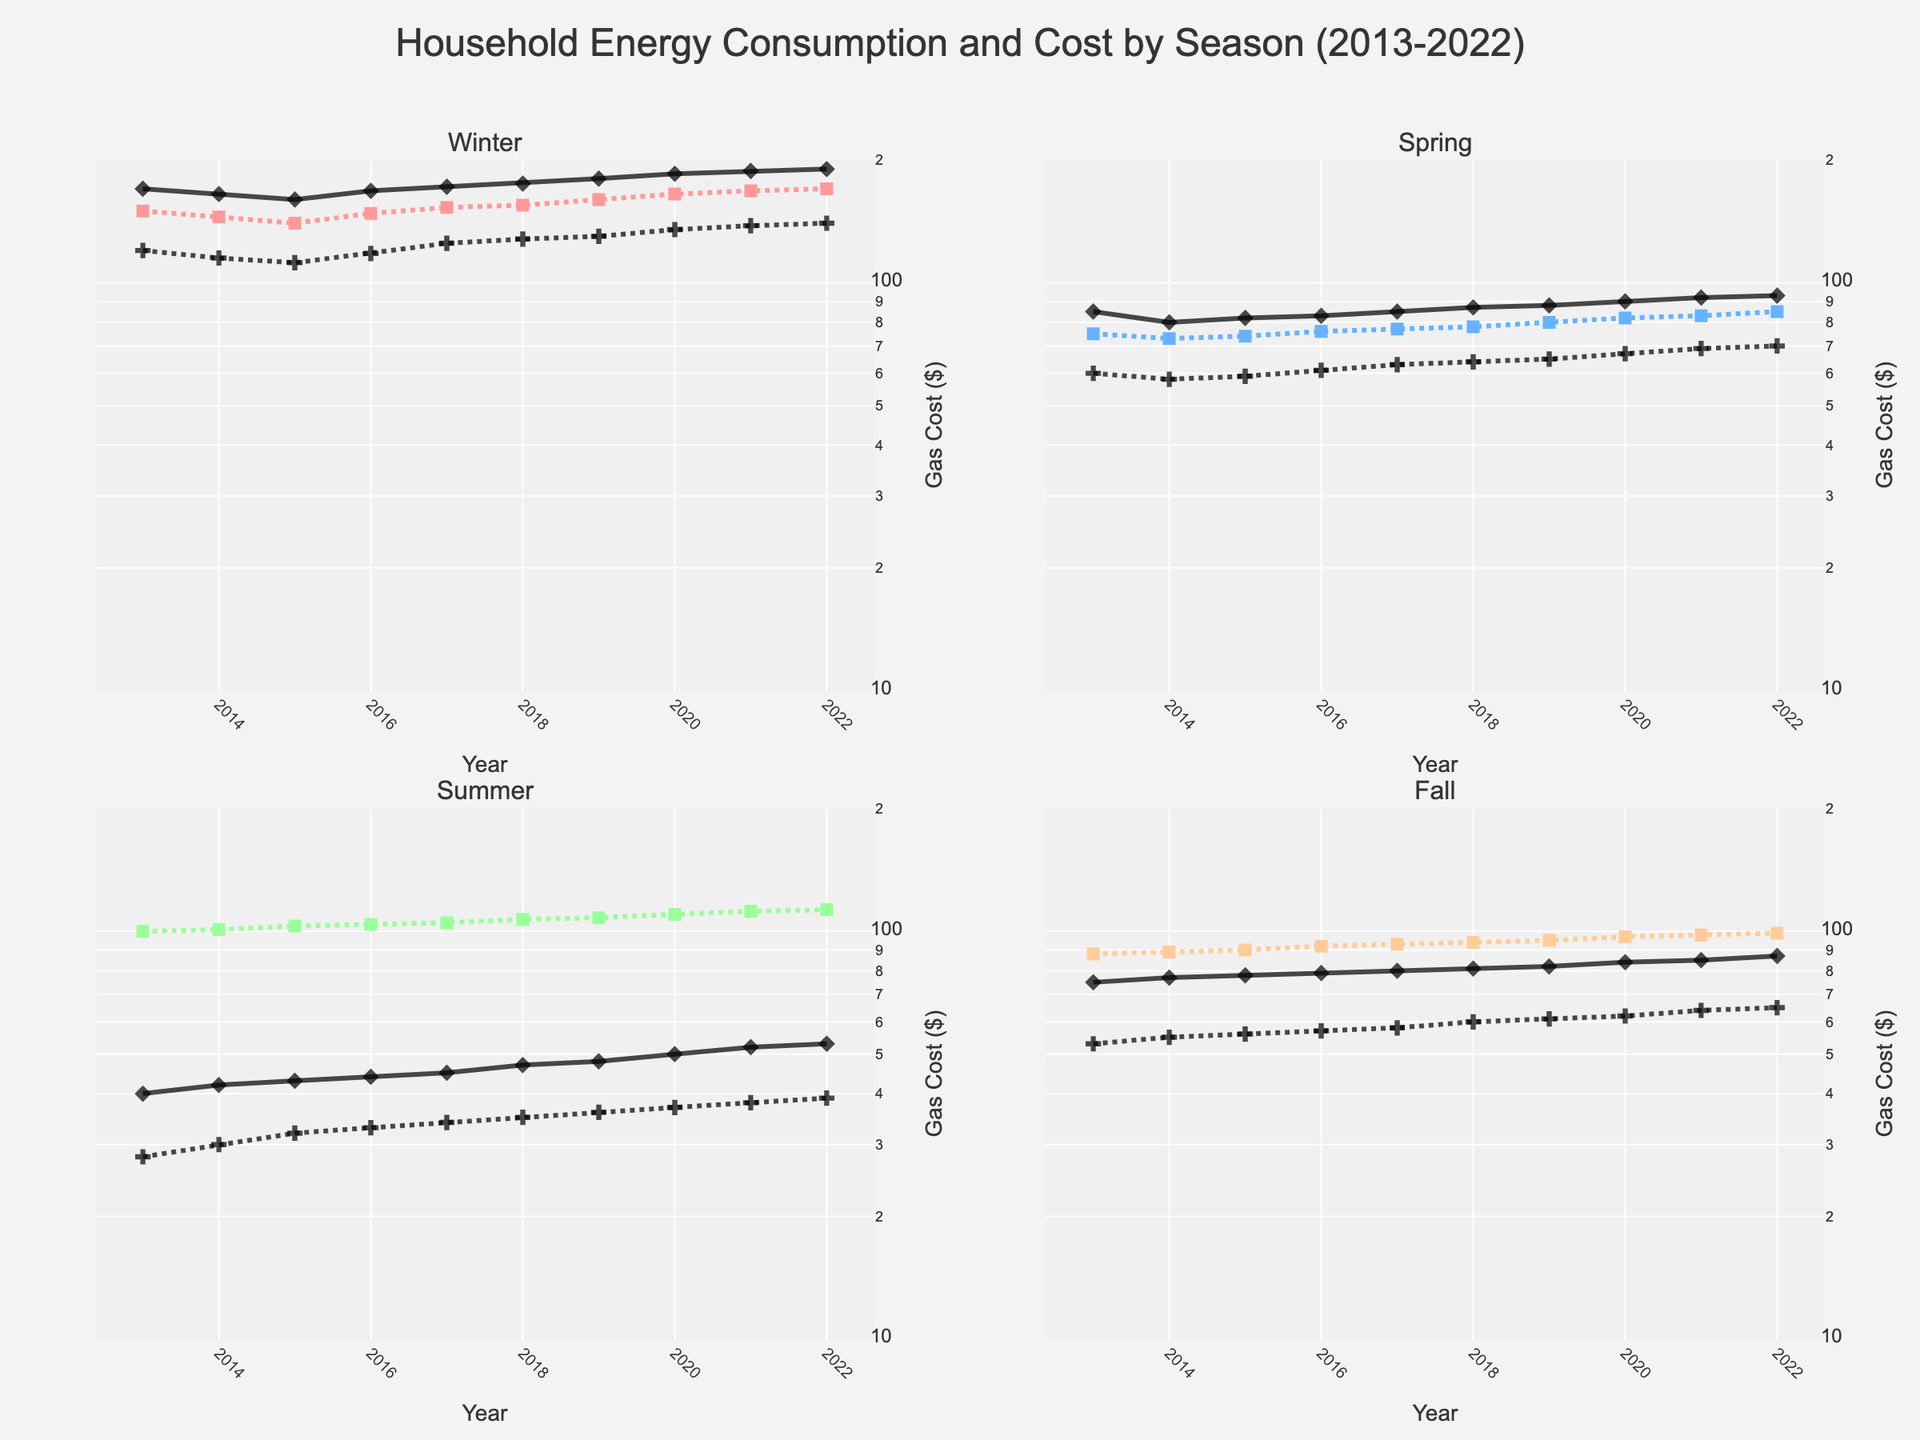Which season has the highest electricity consumption in 2022? The winter subplot shows electricity consumption climbing the highest in 2022, reaching 1400 kWh, more than other seasons.
Answer: Winter Does gas consumption show an increasing trend over the years in the summer season? In the summer subplot, gas consumption starts at 40 therms in 2013 and increases steadily each year, reaching 53 therms in 2022.
Answer: Yes Compare the electricity cost between summer 2015 and fall 2015. In 2015, the summer subplot shows an electricity cost of $103, while the fall subplot shows a cost of $90. Thus, summer has a higher electricity cost compared to fall.
Answer: Summer What is the general trend of gas cost in spring from 2013 to 2022? Gas cost in the spring subplot starts at $60 in 2013 and steadily rises to $70 in 2022, indicating an overall increasing trend.
Answer: Increasing Which season had the lowest gas consumption in 2020? By looking at the 2020 data across subplots, it is evident that the summer subplot shows the lowest gas consumption with 50 therms.
Answer: Summer What has a higher value in winter 2020, electricity cost or gas cost? In the winter subplot for 2020, electricity cost is $165, while gas cost is $135, thus electricity cost is higher.
Answer: Electricity cost What is the difference in electricity consumption between winter 2013 and winter 2022? In winter 2013, electricity consumption is 1200 kWh, and it increases to 1400 kWh in 2022, making the difference 1400 - 120 = 200 kWh.
Answer: 200 kWh Is there a season where both electricity and gas costs decrease over several years? The fall subplot shows both electricity cost (from $88 to $99) and gas cost (from $53 to $65) increasing over the years. Thus, no season shows both costs decreasing.
Answer: No 